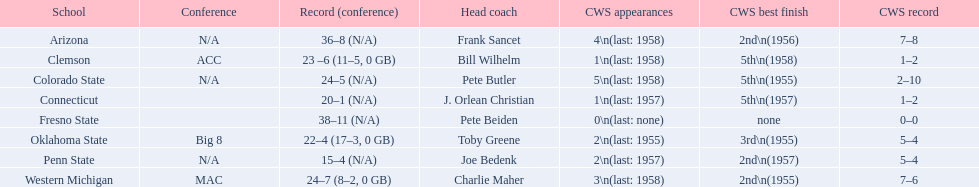What are the teams in the conference? Arizona, Clemson, Colorado State, Connecticut, Fresno State, Oklahoma State, Penn State, Western Michigan. Which have more than 16 wins? Arizona, Clemson, Colorado State, Connecticut, Fresno State, Oklahoma State, Western Michigan. Which had less than 16 wins? Penn State. 